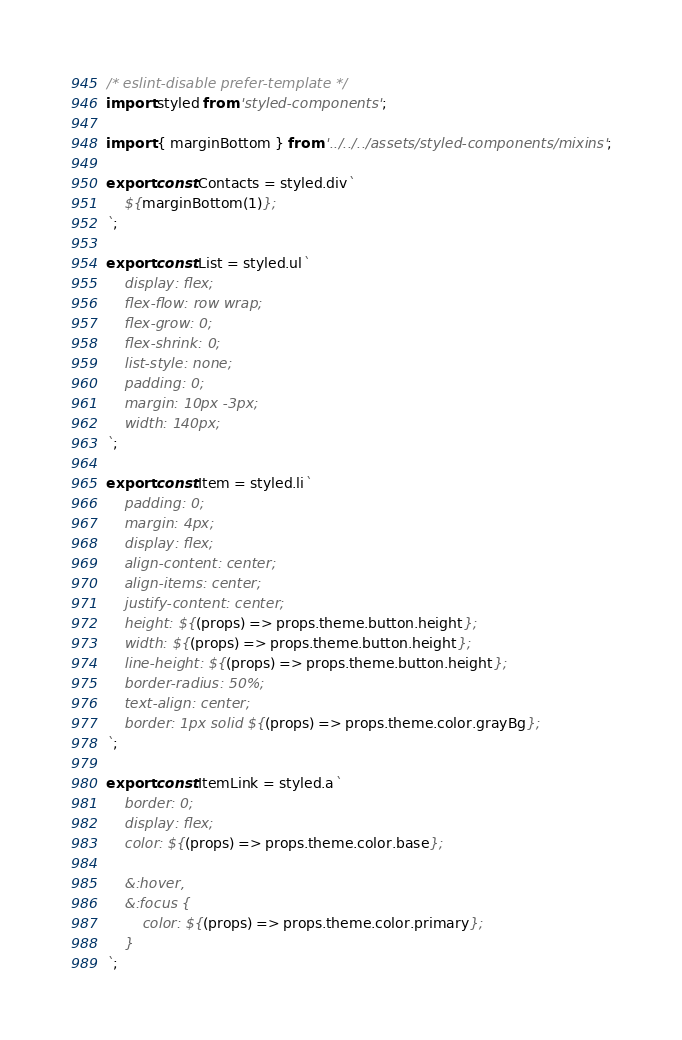<code> <loc_0><loc_0><loc_500><loc_500><_JavaScript_>/* eslint-disable prefer-template */
import styled from 'styled-components';

import { marginBottom } from '../../../assets/styled-components/mixins';

export const Contacts = styled.div`
	${marginBottom(1)};
`;

export const List = styled.ul`
	display: flex;
	flex-flow: row wrap;
	flex-grow: 0;
	flex-shrink: 0;
	list-style: none;
	padding: 0;
	margin: 10px -3px;
	width: 140px;
`;

export const Item = styled.li`
	padding: 0;
	margin: 4px;
	display: flex;
	align-content: center;
	align-items: center;
	justify-content: center;
	height: ${(props) => props.theme.button.height};
	width: ${(props) => props.theme.button.height};
	line-height: ${(props) => props.theme.button.height};
	border-radius: 50%;
	text-align: center;
	border: 1px solid ${(props) => props.theme.color.grayBg};
`;

export const ItemLink = styled.a`
	border: 0;
	display: flex;
	color: ${(props) => props.theme.color.base};

	&:hover,
	&:focus {
		color: ${(props) => props.theme.color.primary};
	}
`;
</code> 